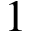Convert formula to latex. <formula><loc_0><loc_0><loc_500><loc_500>1</formula> 